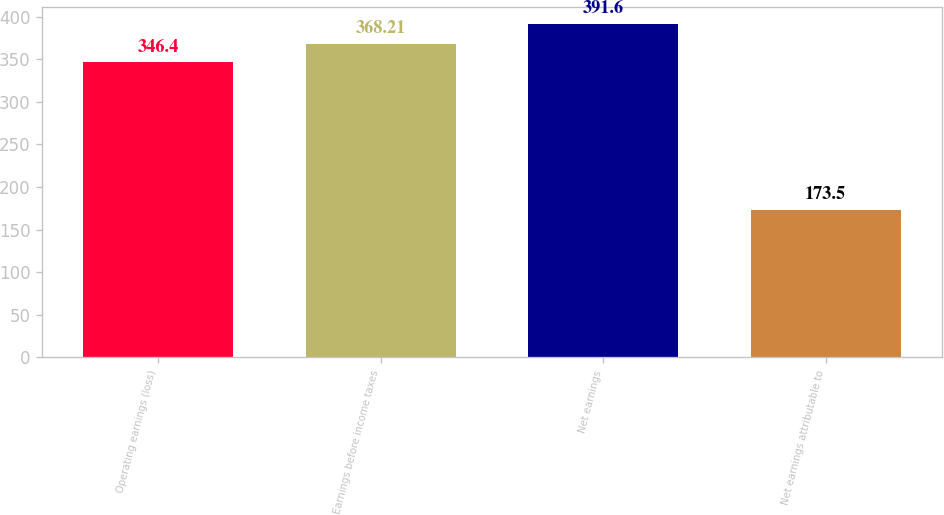<chart> <loc_0><loc_0><loc_500><loc_500><bar_chart><fcel>Operating earnings (loss)<fcel>Earnings before income taxes<fcel>Net earnings<fcel>Net earnings attributable to<nl><fcel>346.4<fcel>368.21<fcel>391.6<fcel>173.5<nl></chart> 